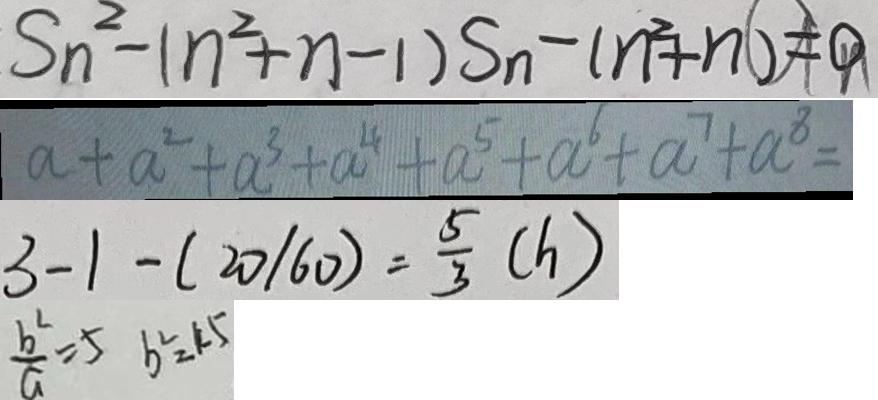<formula> <loc_0><loc_0><loc_500><loc_500>S _ { n } - ( n ^ { 2 } + n - 1 ) S _ { n } - ( n ^ { 2 } + n ) = 0 
 a + a ^ { 2 } + a ^ { 3 } + a ^ { 4 } + a ^ { 5 } + a ^ { 6 } + a ^ { 7 } + a ^ { 8 } = 
 3 - 1 - ( 2 0 / 6 0 ) = \frac { 5 } { 3 } ( h ) 
 \frac { b ^ { 2 } } { a } = 5 b ^ { 2 } = 4 5</formula> 